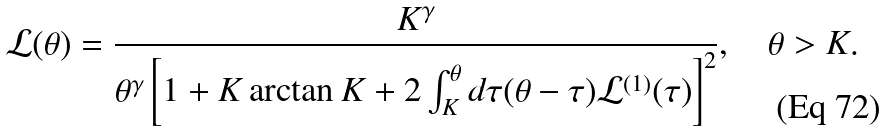<formula> <loc_0><loc_0><loc_500><loc_500>\mathcal { L } ( \theta ) = \frac { K ^ { \gamma } } { \theta ^ { \gamma } \left [ 1 + K \arctan K + 2 \int _ { K } ^ { \theta } d \tau ( \theta - \tau ) \mathcal { L } ^ { ( 1 ) } ( \tau ) \right ] ^ { 2 } } , \quad \theta > K .</formula> 